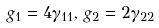Convert formula to latex. <formula><loc_0><loc_0><loc_500><loc_500>g _ { 1 } = 4 \gamma _ { 1 1 } , \, g _ { 2 } = 2 \gamma _ { 2 2 }</formula> 